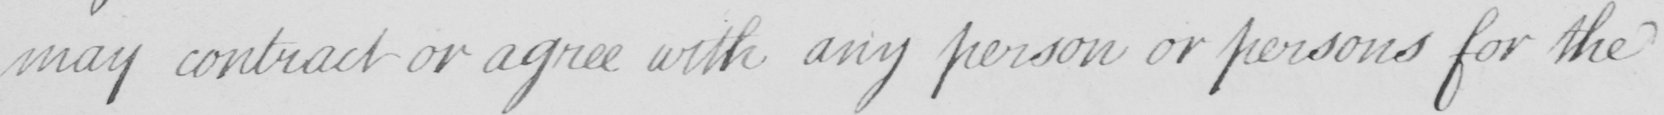What text is written in this handwritten line? may contract or agree with any person or persons for the 